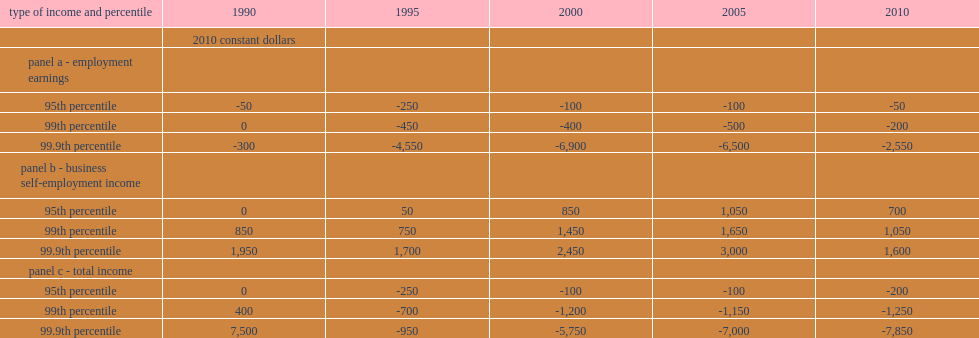What was the difference between the 99.9th percentiles of total income in 2010? 7850. 